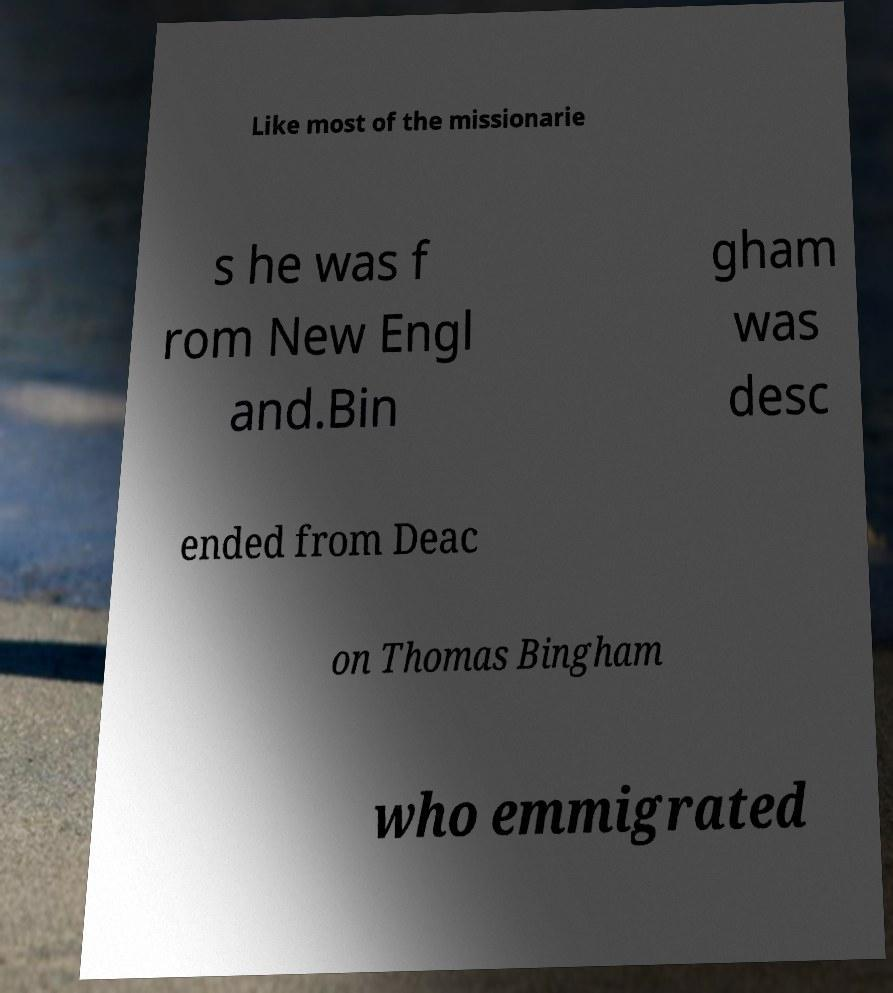Can you read and provide the text displayed in the image?This photo seems to have some interesting text. Can you extract and type it out for me? Like most of the missionarie s he was f rom New Engl and.Bin gham was desc ended from Deac on Thomas Bingham who emmigrated 